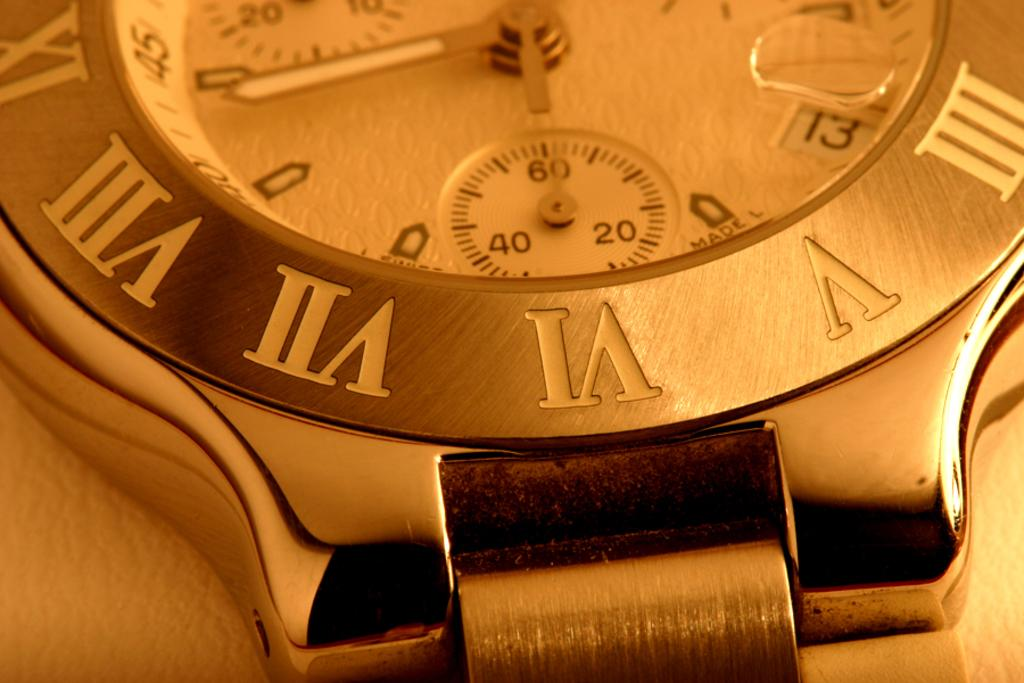<image>
Relay a brief, clear account of the picture shown. A gold watch with the letter V visible. 